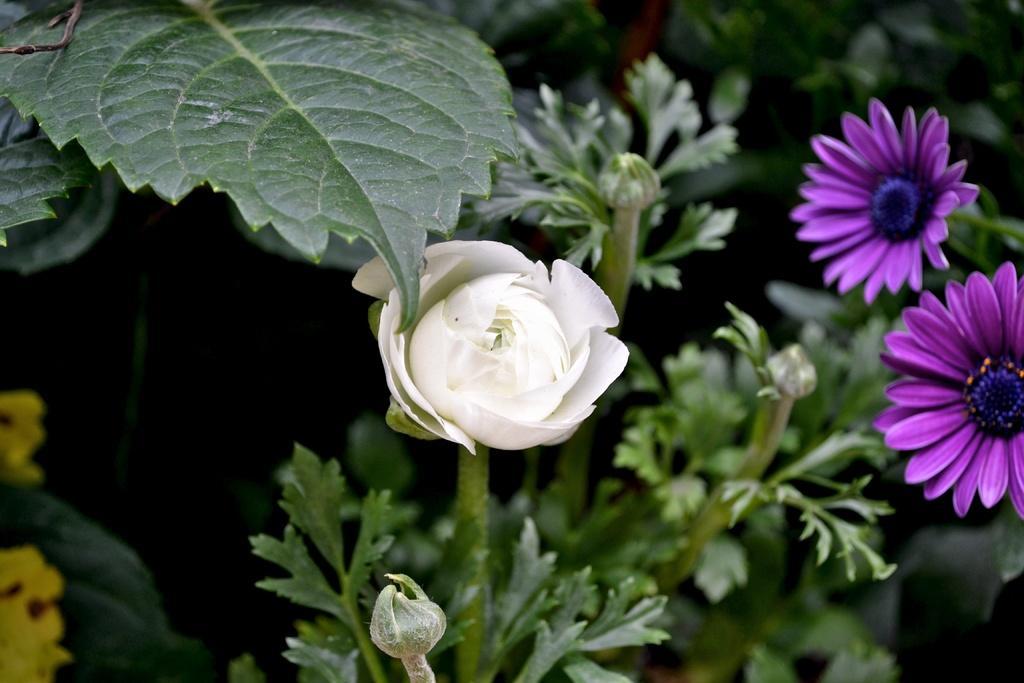Describe this image in one or two sentences. In this picture, we see plants which have flowers and buds. These flowers are in white, violet and yellow color. In the background, we see the trees or plants. This picture is blurred in the background. 